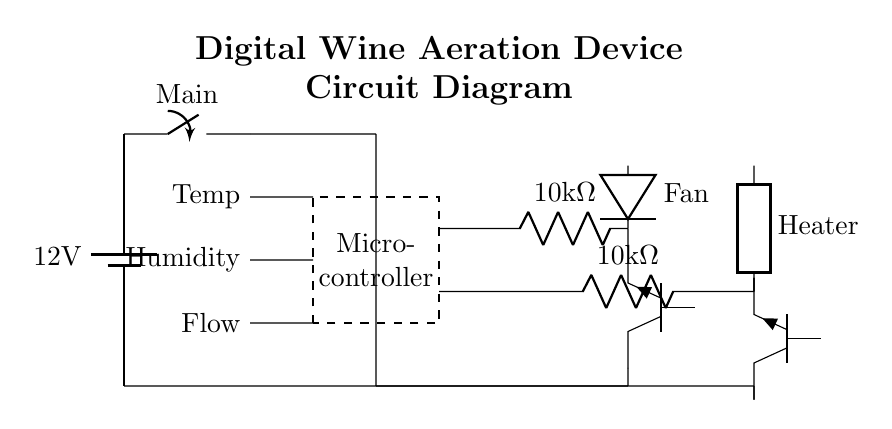What is the voltage of the power supply? The power supply in the circuit diagram is represented as a battery, and it is labeled with a voltage of 12 volts. This indicates the electrical potential provided by the battery for the circuit.
Answer: 12 volts What type of components are used for fan control? The fan control section includes a resistor (10 kiloohms) and a transistor (NPN type). The resistor is used to limit the current, while the NPN transistor functions as a switch to control the fan's operation in the circuit.
Answer: Resistor and NPN transistor How many sensors are included in the circuit? The sensors listed in the circuit diagram include temperature, humidity, and flow sensors. Each is connected as input to the microcontroller to monitor and control the aeration process.
Answer: Three sensors What is the purpose of the heating element in this circuit? The heating element is used in the circuit to warm the wine or facilitate certain chemical reactions that enhance the wine's flavor profiles during the aeration process, thereby improving the sensory experience.
Answer: To enhance flavor profiles What types of control components are used for both fan and heating element? Both the fan and heating element are controlled by similar circuit elements, which are a resistor followed by an NPN transistor. This configuration allows for effective control of high-power loads in the aeration device.
Answer: Resistor and NPN transistor for both Why is a microcontroller necessary in this design? A microcontroller is necessary in this circuit design to process the data from sensors, making decisions based on the gathered information, and controlling the outputs (fan and heater) to optimize the aeration process and improve flavor enhancement.
Answer: To process data and control outputs Which component is responsible for temperature measurement? The temperature sensor is specifically designated in the circuit diagram, labeled as the 'Temp' sensor, which directly measures the temperature of the wine. This information is crucial for adjusting the aeration conditions efficiently.
Answer: Temperature sensor 